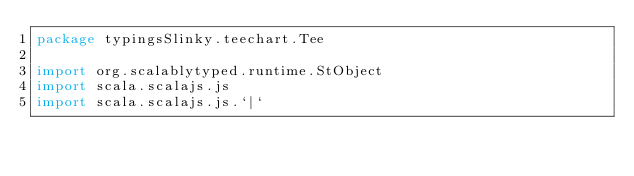Convert code to text. <code><loc_0><loc_0><loc_500><loc_500><_Scala_>package typingsSlinky.teechart.Tee

import org.scalablytyped.runtime.StObject
import scala.scalajs.js
import scala.scalajs.js.`|`</code> 